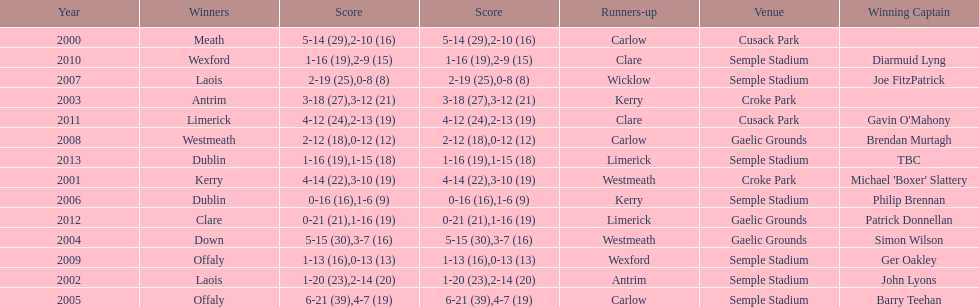Which team was the previous winner before dublin in 2013? Clare. Can you parse all the data within this table? {'header': ['Year', 'Winners', 'Score', 'Score', 'Runners-up', 'Venue', 'Winning Captain'], 'rows': [['2000', 'Meath', '5-14 (29)', '2-10 (16)', 'Carlow', 'Cusack Park', ''], ['2010', 'Wexford', '1-16 (19)', '2-9 (15)', 'Clare', 'Semple Stadium', 'Diarmuid Lyng'], ['2007', 'Laois', '2-19 (25)', '0-8 (8)', 'Wicklow', 'Semple Stadium', 'Joe FitzPatrick'], ['2003', 'Antrim', '3-18 (27)', '3-12 (21)', 'Kerry', 'Croke Park', ''], ['2011', 'Limerick', '4-12 (24)', '2-13 (19)', 'Clare', 'Cusack Park', "Gavin O'Mahony"], ['2008', 'Westmeath', '2-12 (18)', '0-12 (12)', 'Carlow', 'Gaelic Grounds', 'Brendan Murtagh'], ['2013', 'Dublin', '1-16 (19)', '1-15 (18)', 'Limerick', 'Semple Stadium', 'TBC'], ['2001', 'Kerry', '4-14 (22)', '3-10 (19)', 'Westmeath', 'Croke Park', "Michael 'Boxer' Slattery"], ['2006', 'Dublin', '0-16 (16)', '1-6 (9)', 'Kerry', 'Semple Stadium', 'Philip Brennan'], ['2012', 'Clare', '0-21 (21)', '1-16 (19)', 'Limerick', 'Gaelic Grounds', 'Patrick Donnellan'], ['2004', 'Down', '5-15 (30)', '3-7 (16)', 'Westmeath', 'Gaelic Grounds', 'Simon Wilson'], ['2009', 'Offaly', '1-13 (16)', '0-13 (13)', 'Wexford', 'Semple Stadium', 'Ger Oakley'], ['2002', 'Laois', '1-20 (23)', '2-14 (20)', 'Antrim', 'Semple Stadium', 'John Lyons'], ['2005', 'Offaly', '6-21 (39)', '4-7 (19)', 'Carlow', 'Semple Stadium', 'Barry Teehan']]} 